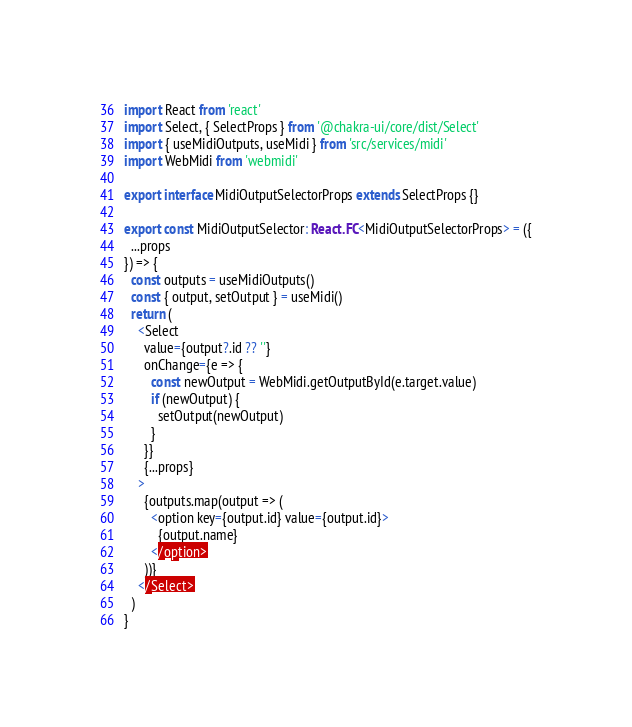Convert code to text. <code><loc_0><loc_0><loc_500><loc_500><_TypeScript_>import React from 'react'
import Select, { SelectProps } from '@chakra-ui/core/dist/Select'
import { useMidiOutputs, useMidi } from 'src/services/midi'
import WebMidi from 'webmidi'

export interface MidiOutputSelectorProps extends SelectProps {}

export const MidiOutputSelector: React.FC<MidiOutputSelectorProps> = ({
  ...props
}) => {
  const outputs = useMidiOutputs()
  const { output, setOutput } = useMidi()
  return (
    <Select
      value={output?.id ?? ''}
      onChange={e => {
        const newOutput = WebMidi.getOutputById(e.target.value)
        if (newOutput) {
          setOutput(newOutput)
        }
      }}
      {...props}
    >
      {outputs.map(output => (
        <option key={output.id} value={output.id}>
          {output.name}
        </option>
      ))}
    </Select>
  )
}
</code> 